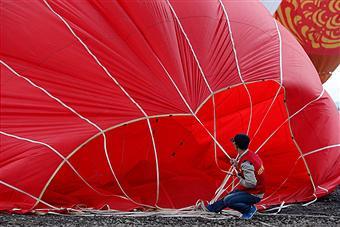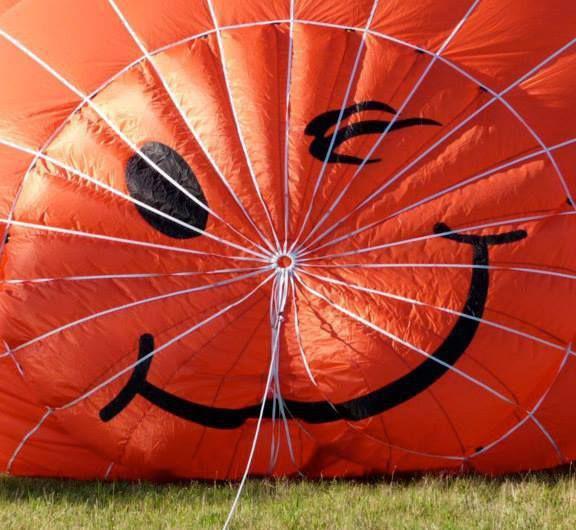The first image is the image on the left, the second image is the image on the right. Analyze the images presented: Is the assertion "A blue circle design is at the top of the balloon on the right." valid? Answer yes or no. No. The first image is the image on the left, the second image is the image on the right. Given the left and right images, does the statement "The fabric of the hot-air balloon in the left image features at least three colors." hold true? Answer yes or no. No. 